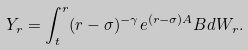Convert formula to latex. <formula><loc_0><loc_0><loc_500><loc_500>Y _ { r } = \int _ { t } ^ { r } ( r - \sigma ) ^ { - \gamma } e ^ { ( r - \sigma ) A } B d W _ { r } .</formula> 